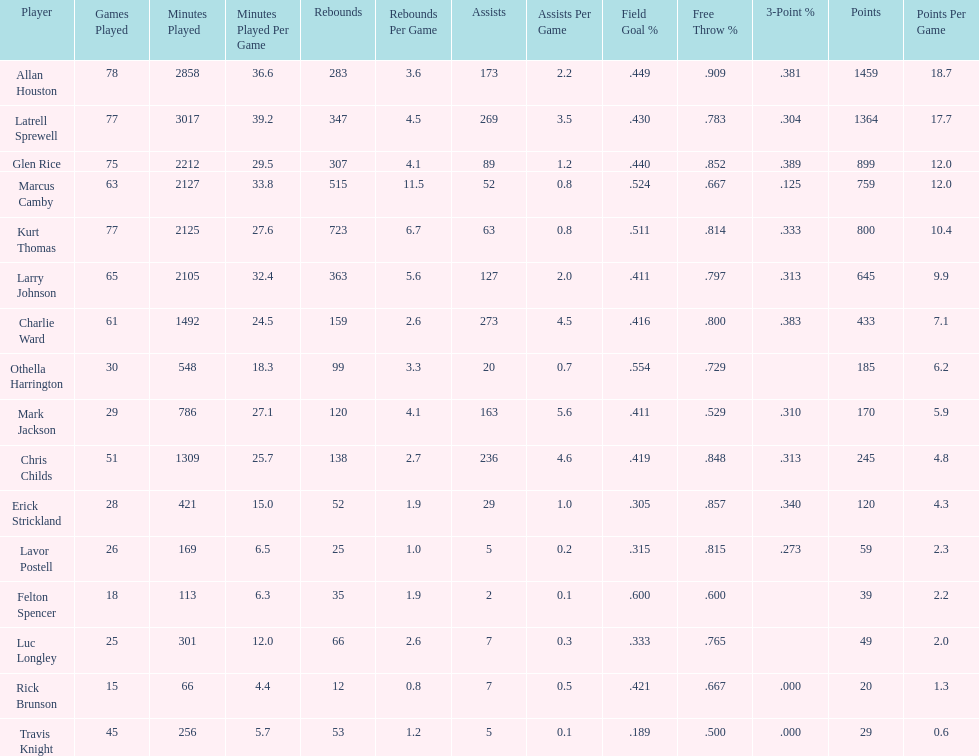Count of team members. 16. Would you be able to parse every entry in this table? {'header': ['Player', 'Games Played', 'Minutes Played', 'Minutes Played Per Game', 'Rebounds', 'Rebounds Per Game', 'Assists', 'Assists Per Game', 'Field Goal\xa0%', 'Free Throw\xa0%', '3-Point\xa0%', 'Points', 'Points Per Game'], 'rows': [['Allan Houston', '78', '2858', '36.6', '283', '3.6', '173', '2.2', '.449', '.909', '.381', '1459', '18.7'], ['Latrell Sprewell', '77', '3017', '39.2', '347', '4.5', '269', '3.5', '.430', '.783', '.304', '1364', '17.7'], ['Glen Rice', '75', '2212', '29.5', '307', '4.1', '89', '1.2', '.440', '.852', '.389', '899', '12.0'], ['Marcus Camby', '63', '2127', '33.8', '515', '11.5', '52', '0.8', '.524', '.667', '.125', '759', '12.0'], ['Kurt Thomas', '77', '2125', '27.6', '723', '6.7', '63', '0.8', '.511', '.814', '.333', '800', '10.4'], ['Larry Johnson', '65', '2105', '32.4', '363', '5.6', '127', '2.0', '.411', '.797', '.313', '645', '9.9'], ['Charlie Ward', '61', '1492', '24.5', '159', '2.6', '273', '4.5', '.416', '.800', '.383', '433', '7.1'], ['Othella Harrington', '30', '548', '18.3', '99', '3.3', '20', '0.7', '.554', '.729', '', '185', '6.2'], ['Mark Jackson', '29', '786', '27.1', '120', '4.1', '163', '5.6', '.411', '.529', '.310', '170', '5.9'], ['Chris Childs', '51', '1309', '25.7', '138', '2.7', '236', '4.6', '.419', '.848', '.313', '245', '4.8'], ['Erick Strickland', '28', '421', '15.0', '52', '1.9', '29', '1.0', '.305', '.857', '.340', '120', '4.3'], ['Lavor Postell', '26', '169', '6.5', '25', '1.0', '5', '0.2', '.315', '.815', '.273', '59', '2.3'], ['Felton Spencer', '18', '113', '6.3', '35', '1.9', '2', '0.1', '.600', '.600', '', '39', '2.2'], ['Luc Longley', '25', '301', '12.0', '66', '2.6', '7', '0.3', '.333', '.765', '', '49', '2.0'], ['Rick Brunson', '15', '66', '4.4', '12', '0.8', '7', '0.5', '.421', '.667', '.000', '20', '1.3'], ['Travis Knight', '45', '256', '5.7', '53', '1.2', '5', '0.1', '.189', '.500', '.000', '29', '0.6']]} 